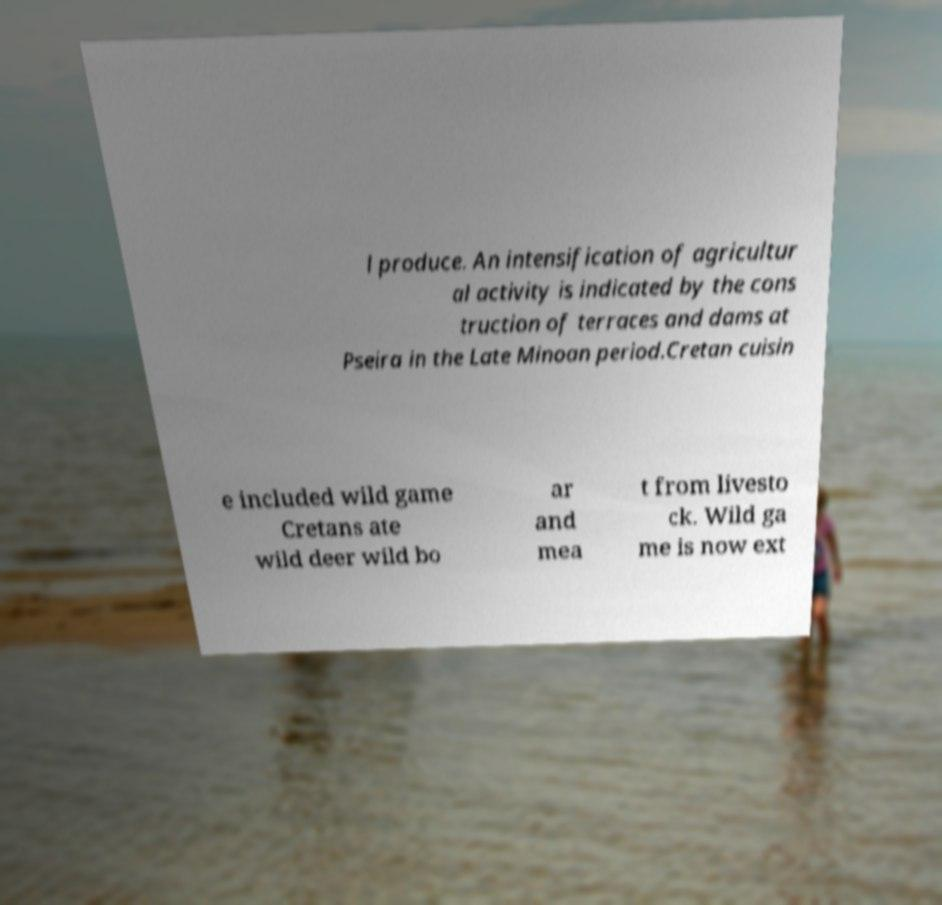For documentation purposes, I need the text within this image transcribed. Could you provide that? l produce. An intensification of agricultur al activity is indicated by the cons truction of terraces and dams at Pseira in the Late Minoan period.Cretan cuisin e included wild game Cretans ate wild deer wild bo ar and mea t from livesto ck. Wild ga me is now ext 